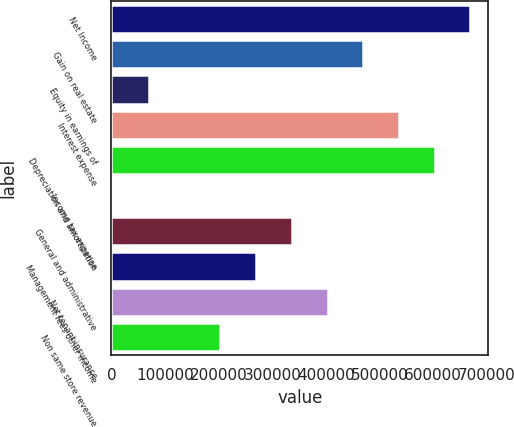Convert chart. <chart><loc_0><loc_0><loc_500><loc_500><bar_chart><fcel>Net Income<fcel>Gain on real estate<fcel>Equity in earnings of<fcel>Interest expense<fcel>Depreciation and amortization<fcel>Income tax expense<fcel>General and administrative<fcel>Management fees other income<fcel>Net tenant insurance<fcel>Non same store revenue<nl><fcel>669417<fcel>469679<fcel>70204.2<fcel>536259<fcel>602838<fcel>3625<fcel>336521<fcel>269942<fcel>403100<fcel>203363<nl></chart> 